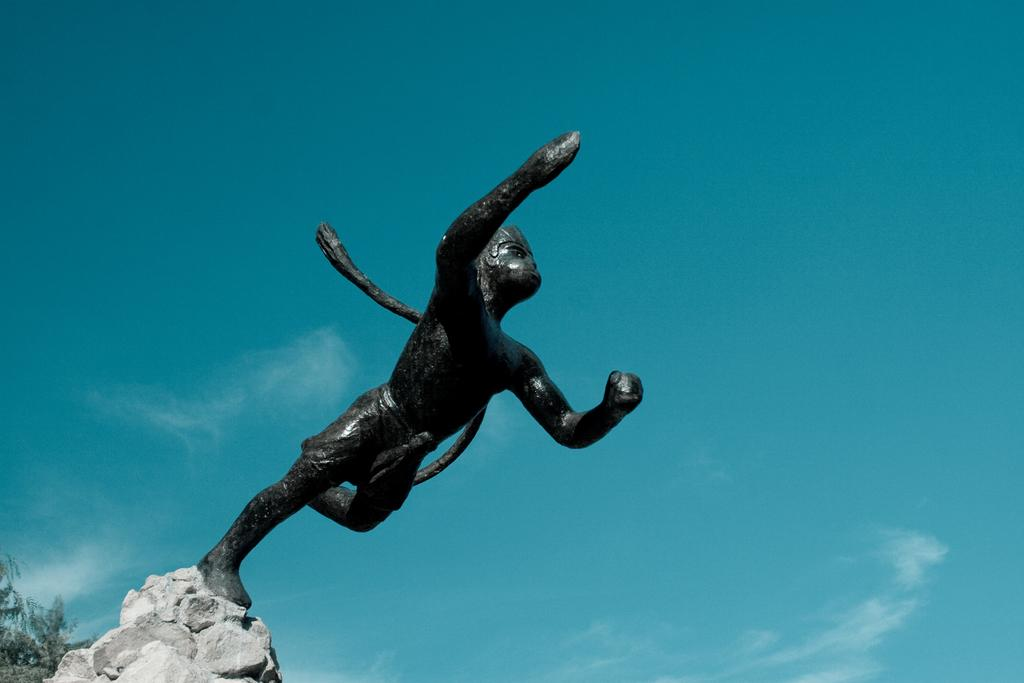What is the main subject in the image? There is a statue in the image. What other objects or elements can be seen in the image? There are stones and leaves visible in the image. What can be seen in the background of the image? The sky is visible in the background of the image. How many layers of cake can be seen in the image? There is no cake present in the image. What color are the eyes of the statue in the image? The image does not show the statue's eyes, so it is not possible to determine their color. 